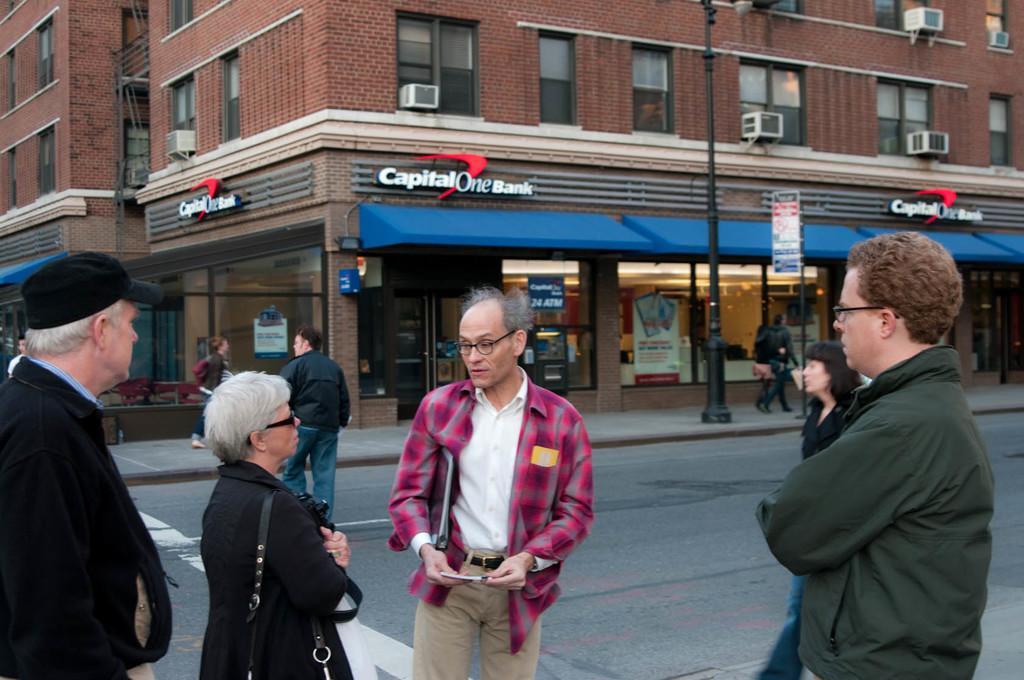How would you summarize this image in a sentence or two? In this image we can see people. Some are wearing specs. One person is wearing cap. Also there is a pole and sign board with a pole. In the back there is a sidewalk and a road. In the background there are buildings with windows. Also there are name boards on the buildings. 